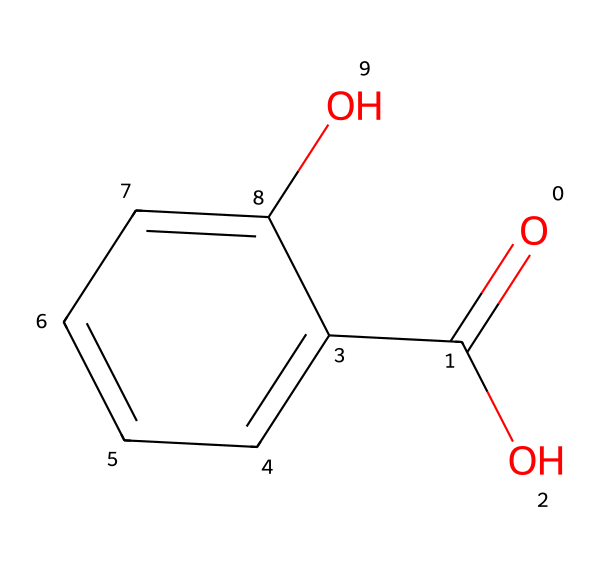What is the name of this chemical? The chemical structure presented is identified as salicylic acid, which is evident from its recognizable functional groups and overall arrangement of atoms.
Answer: salicylic acid How many oxygen atoms are present in this structure? Looking at the structure, we can count the number of oxygen atoms. There are two distinct oxygen atoms included in the structure.
Answer: two What functional groups are present in salicylic acid? The structure contains a carboxylic acid (–COOH) and a hydroxyl group (–OH) attached to the aromatic ring, both of which are critical functional groups in salicylic acid.
Answer: carboxylic acid and hydroxyl group How many carbon atoms are in the structure? By examining the structure, we can identify the total number of carbon atoms which includes those in the aromatic ring and the carboxylic acid part; adding them together gives us a total of seven carbon atoms.
Answer: seven What property does the hydroxyl group confer to salicylic acid? The presence of the hydroxyl group is responsible for the increase in solubility of salicylic acid in water, which is essential for its effectiveness in face washes in treating acne.
Answer: solubility Is salicylic acid an aromatic compound? Yes, the chemical structure shows a benzene ring, which indicates that salicylic acid is indeed an aromatic compound. This property is significant in its stability and reactivity.
Answer: yes 